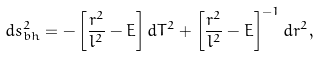<formula> <loc_0><loc_0><loc_500><loc_500>d s _ { b h } ^ { 2 } = - \left [ \frac { r ^ { 2 } } { l ^ { 2 } } - E \right ] d T ^ { 2 } + \left [ \frac { r ^ { 2 } } { l ^ { 2 } } - E \right ] ^ { - 1 } d r ^ { 2 } ,</formula> 